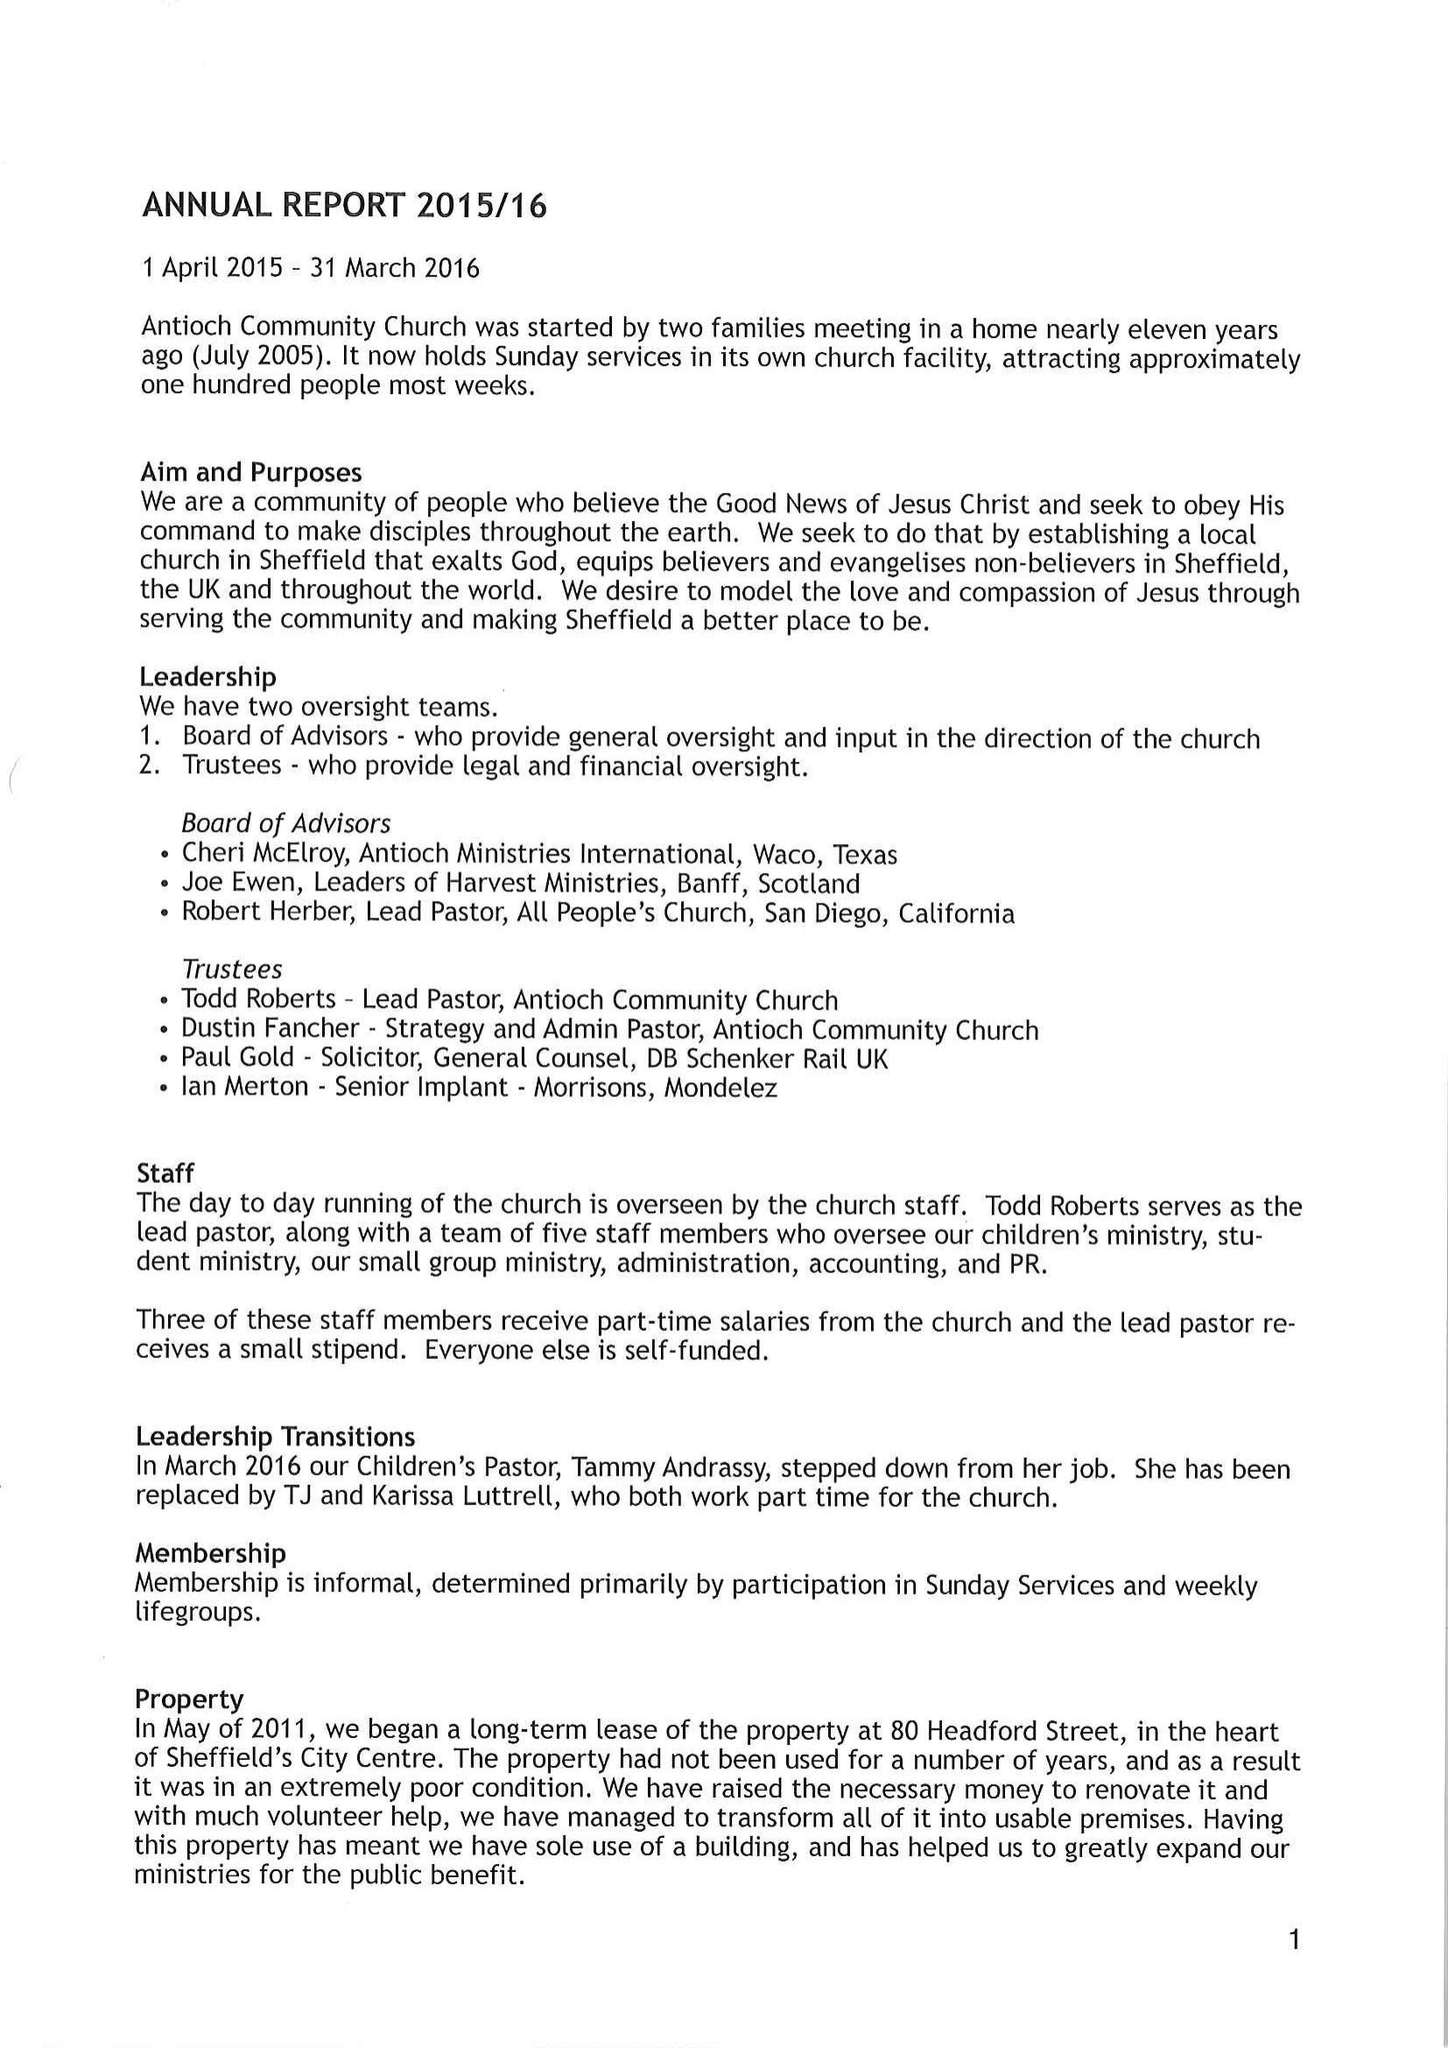What is the value for the address__postcode?
Answer the question using a single word or phrase. None 